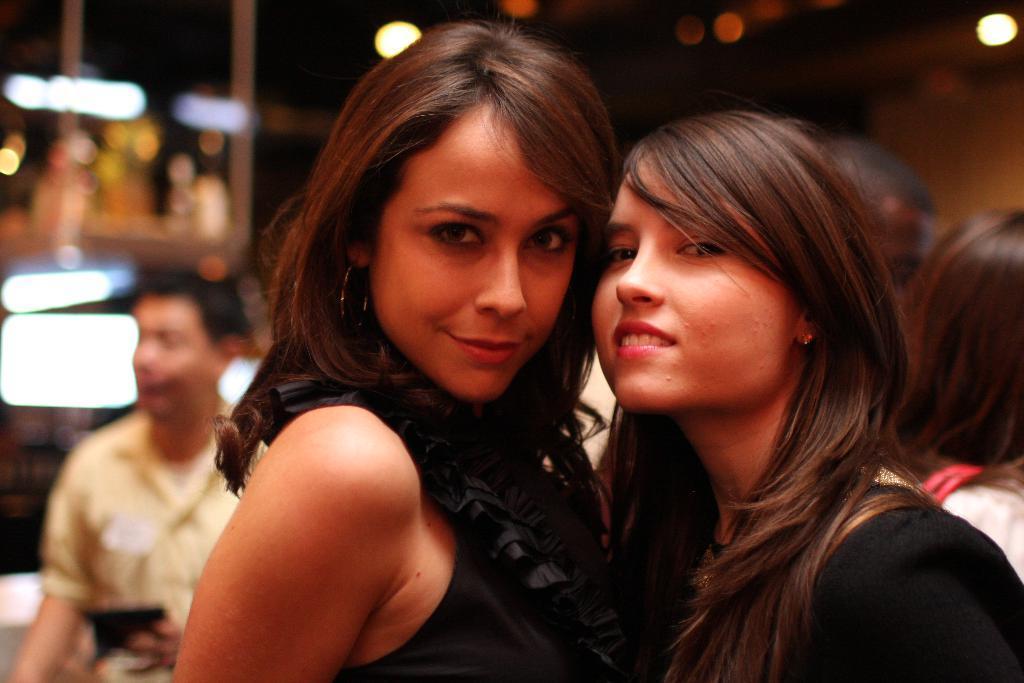Can you describe this image briefly? In this image in the front there are women standing and smiling. In the background there is a man standing wearing yellow colour shirt and there are lights. 